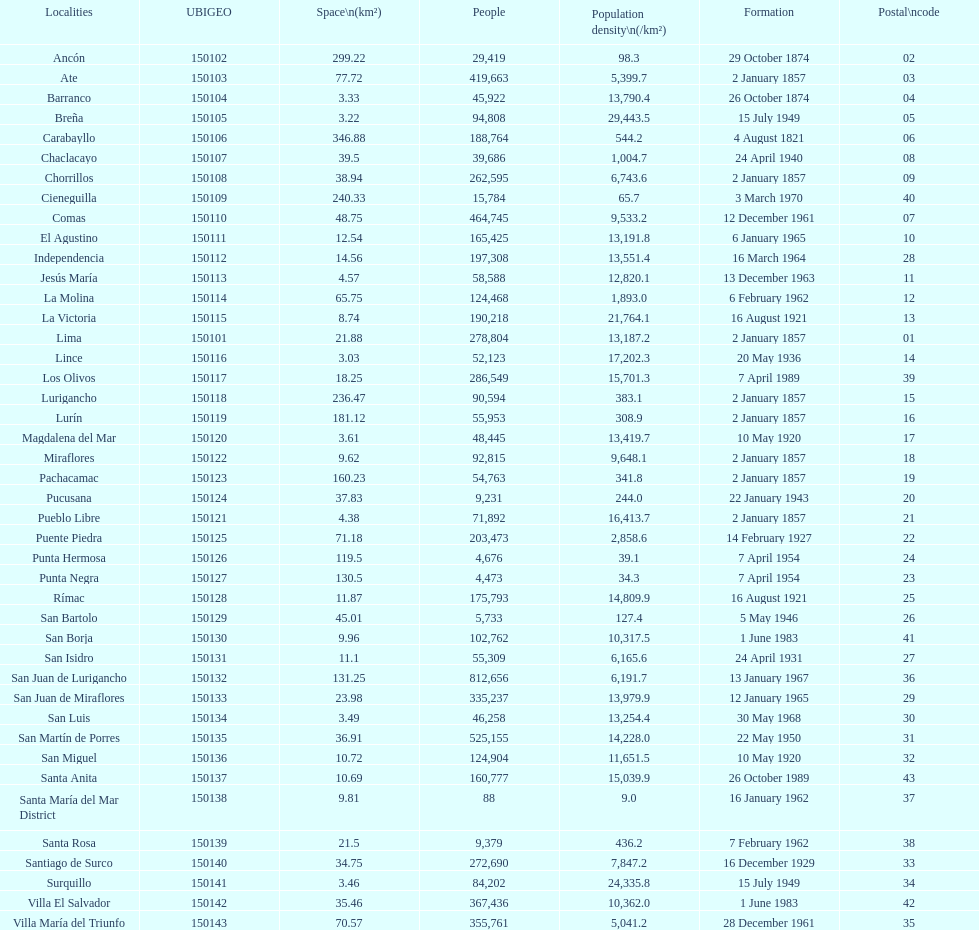What zone has the minimum population density? Santa María del Mar District. 